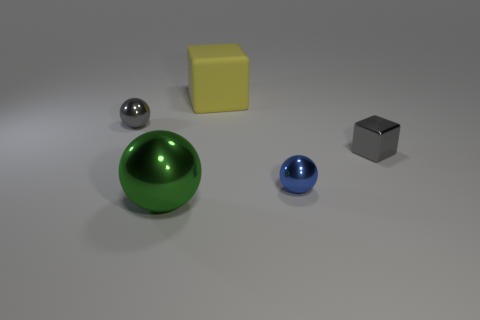What number of blocks are either gray shiny objects or big metallic things?
Keep it short and to the point. 1. There is a tiny metal thing left of the big yellow thing that is to the left of the small blue metallic sphere; what is its color?
Offer a terse response. Gray. There is a metallic cube; does it have the same color as the tiny shiny thing on the left side of the large green metal object?
Give a very brief answer. Yes. What size is the green object that is the same material as the blue thing?
Keep it short and to the point. Large. There is a tiny gray thing that is in front of the small shiny object that is behind the metal cube; are there any gray metal objects that are left of it?
Keep it short and to the point. Yes. What number of cyan matte cylinders are the same size as the green metal ball?
Give a very brief answer. 0. Do the gray thing left of the small gray block and the metallic ball in front of the small blue shiny sphere have the same size?
Keep it short and to the point. No. What shape is the shiny object that is to the left of the blue metal ball and behind the large green metallic ball?
Provide a short and direct response. Sphere. Is there a small object that has the same color as the metallic cube?
Provide a short and direct response. Yes. Is there a yellow object?
Your answer should be compact. Yes. 